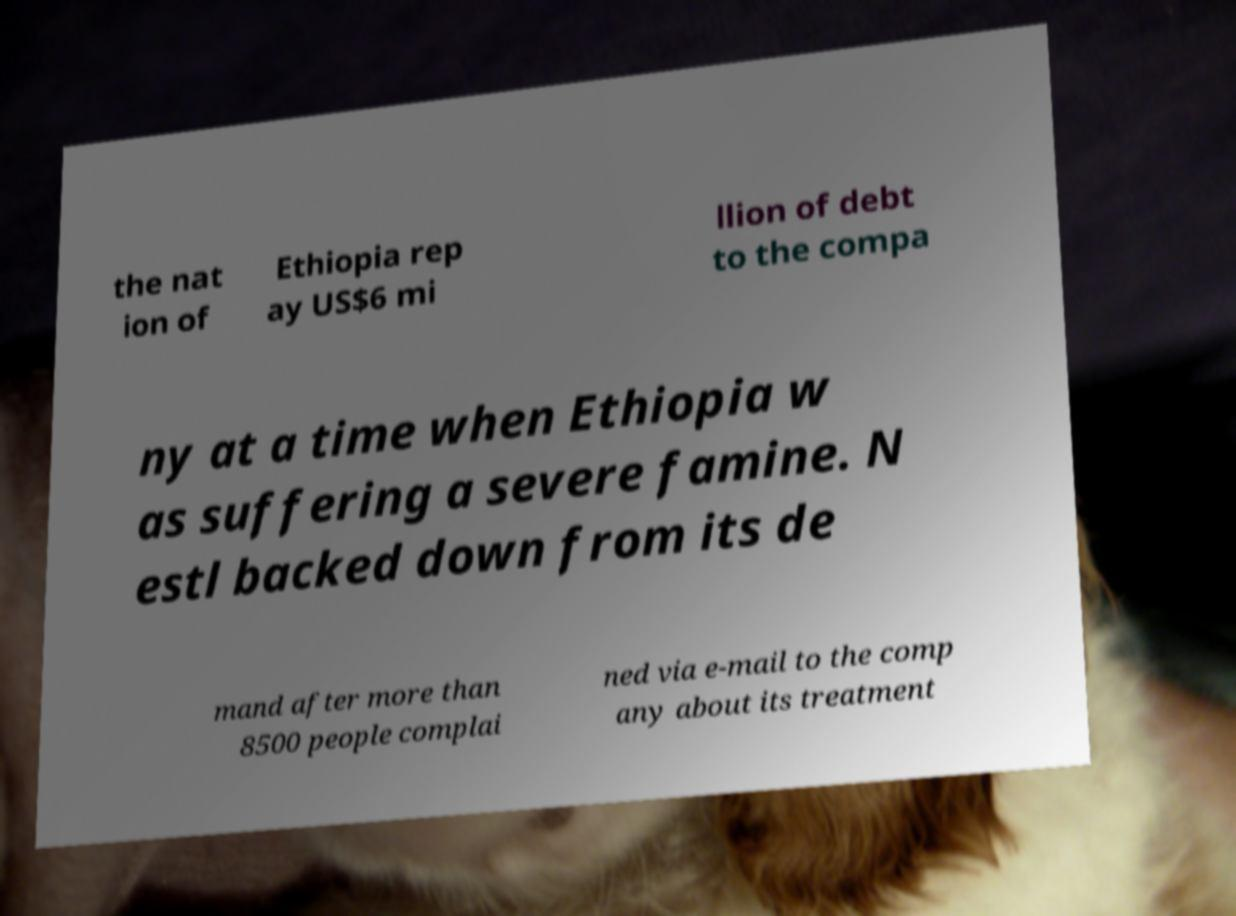Could you extract and type out the text from this image? the nat ion of Ethiopia rep ay US$6 mi llion of debt to the compa ny at a time when Ethiopia w as suffering a severe famine. N estl backed down from its de mand after more than 8500 people complai ned via e-mail to the comp any about its treatment 